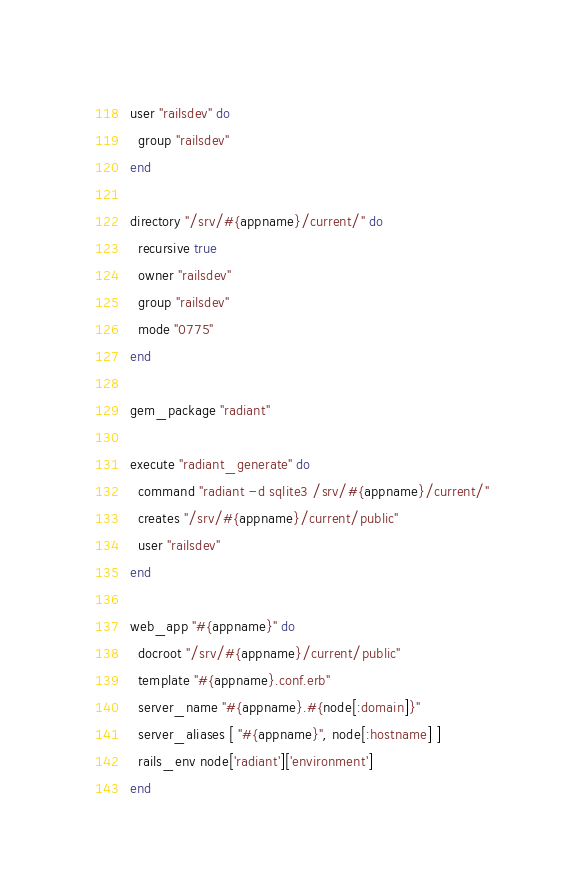<code> <loc_0><loc_0><loc_500><loc_500><_Ruby_>user "railsdev" do
  group "railsdev"
end

directory "/srv/#{appname}/current/" do
  recursive true
  owner "railsdev"
  group "railsdev"
  mode "0775"
end

gem_package "radiant"

execute "radiant_generate" do
  command "radiant -d sqlite3 /srv/#{appname}/current/"
  creates "/srv/#{appname}/current/public"
  user "railsdev"
end

web_app "#{appname}" do
  docroot "/srv/#{appname}/current/public"
  template "#{appname}.conf.erb"
  server_name "#{appname}.#{node[:domain]}"
  server_aliases [ "#{appname}", node[:hostname] ]
  rails_env node['radiant']['environment']
end
</code> 